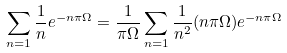<formula> <loc_0><loc_0><loc_500><loc_500>\sum _ { n = 1 } \frac { 1 } { n } e ^ { - n \pi \Omega } = \frac { 1 } { \pi \Omega } \sum _ { n = 1 } \frac { 1 } { n ^ { 2 } } ( n \pi \Omega ) e ^ { - n \pi \Omega }</formula> 